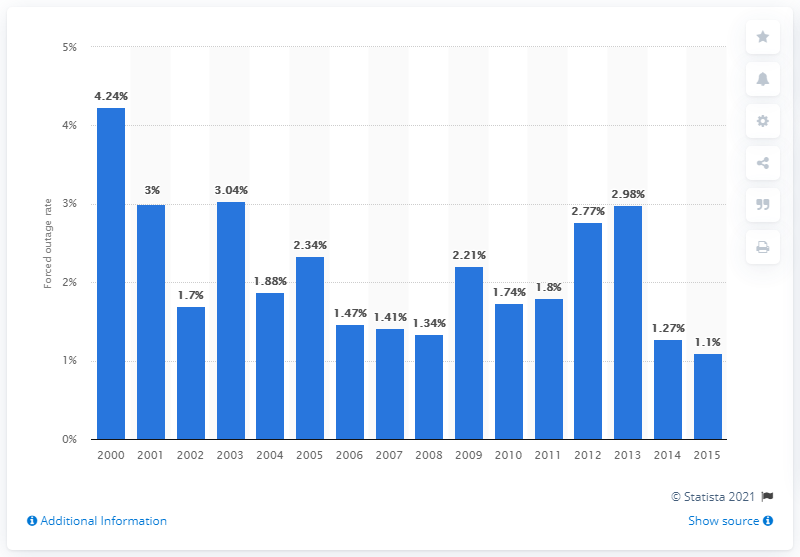List a handful of essential elements in this visual. In 2005, the forced outage rate of U.S. nuclear reactors was 2.34. 